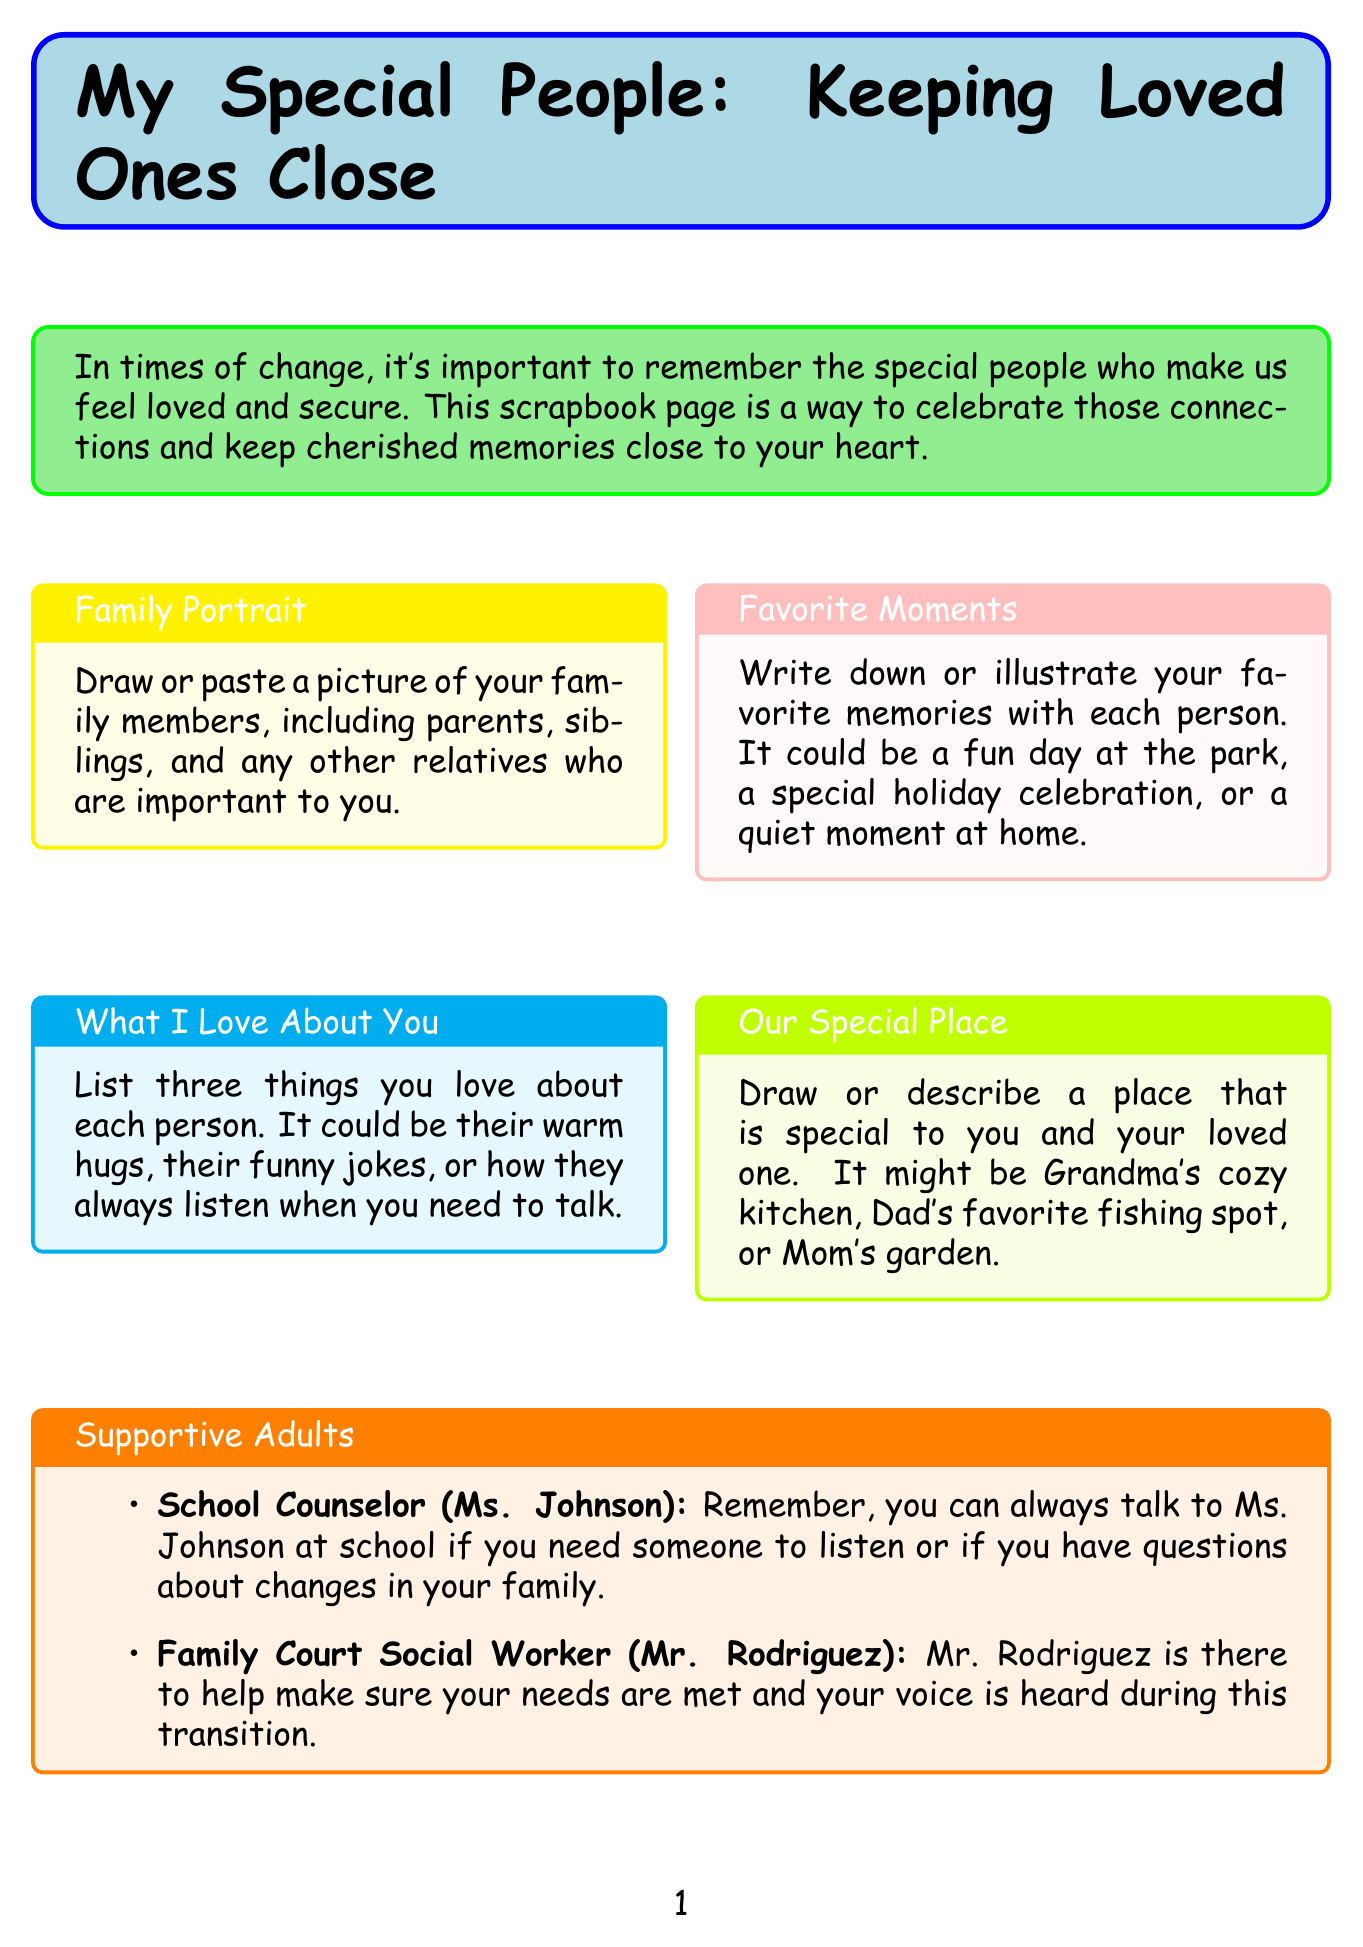What is the title of the newsletter? The title is clearly stated at the beginning of the document.
Answer: My Special People: Keeping Loved Ones Close Who is the school counselor mentioned? The document lists the names and roles of supportive adults present in it.
Answer: Ms. Johnson What activity helps express daily feelings? The document outlines various comforting activities with specific titles.
Answer: Creating a 'Feelings Journal' What is one thing you should draw in the Family Portrait section? The description tells what to include in the Family Portrait section.
Answer: Picture of your family members How many things should you list about each person in "What I Love About You"? This information is specified in the title of the section describing the task.
Answer: Three Who is responsible for ensuring your needs are met during transitions? The document provides roles and names of supportive adults for the child.
Answer: Mr. Rodriguez What color is used for the background of the "What I Love About You" section? The document describes the colors designated for each section's background.
Answer: Cyan What should you decorate for the 'Hug Button' activity? The description explains the item to be decorated in this comforting activity.
Answer: Small button 